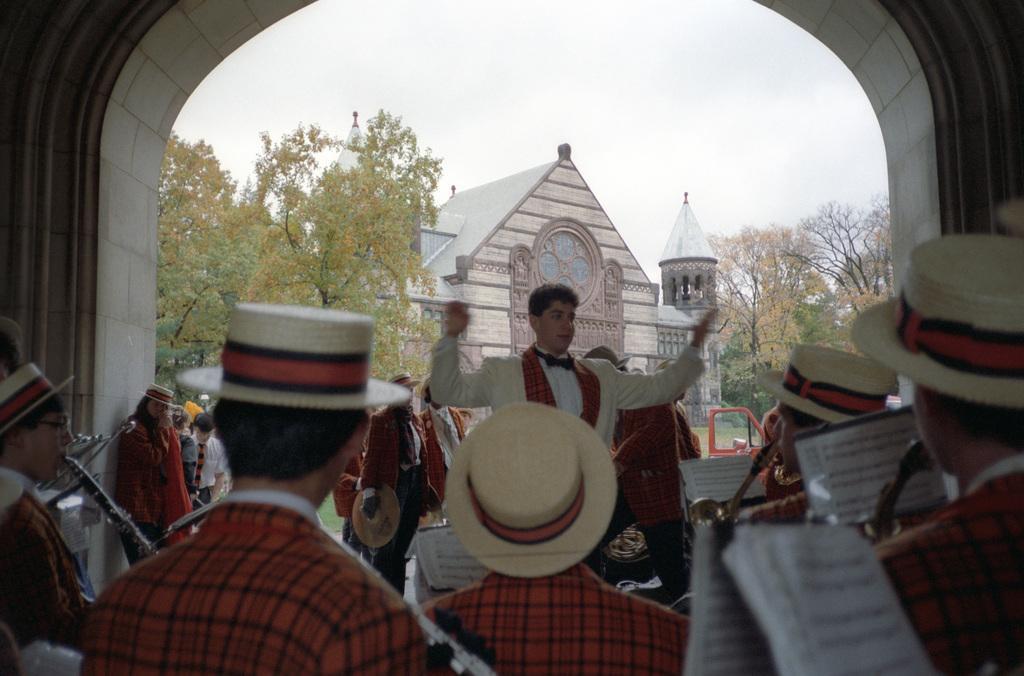Describe this image in one or two sentences. In this picture we can see a man wearing white suit giving instruction to the band person for playing the music. Behind there is a old church and in front top side we can see big arch. 